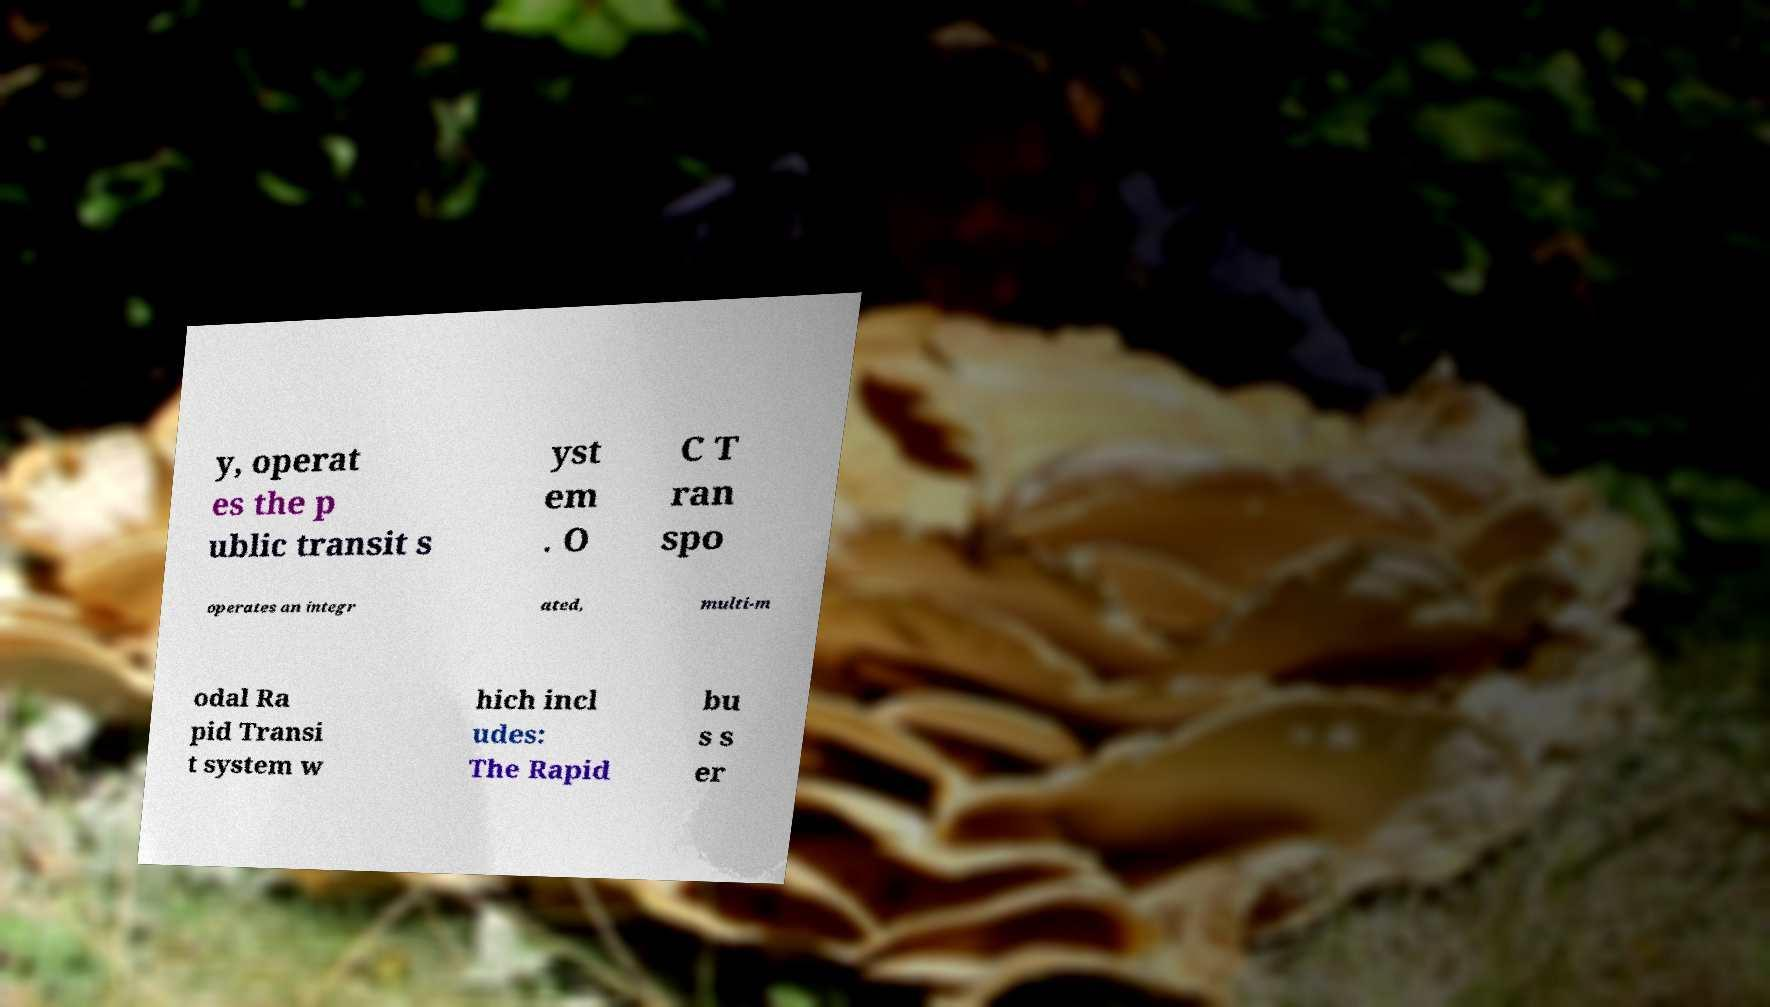There's text embedded in this image that I need extracted. Can you transcribe it verbatim? y, operat es the p ublic transit s yst em . O C T ran spo operates an integr ated, multi-m odal Ra pid Transi t system w hich incl udes: The Rapid bu s s er 